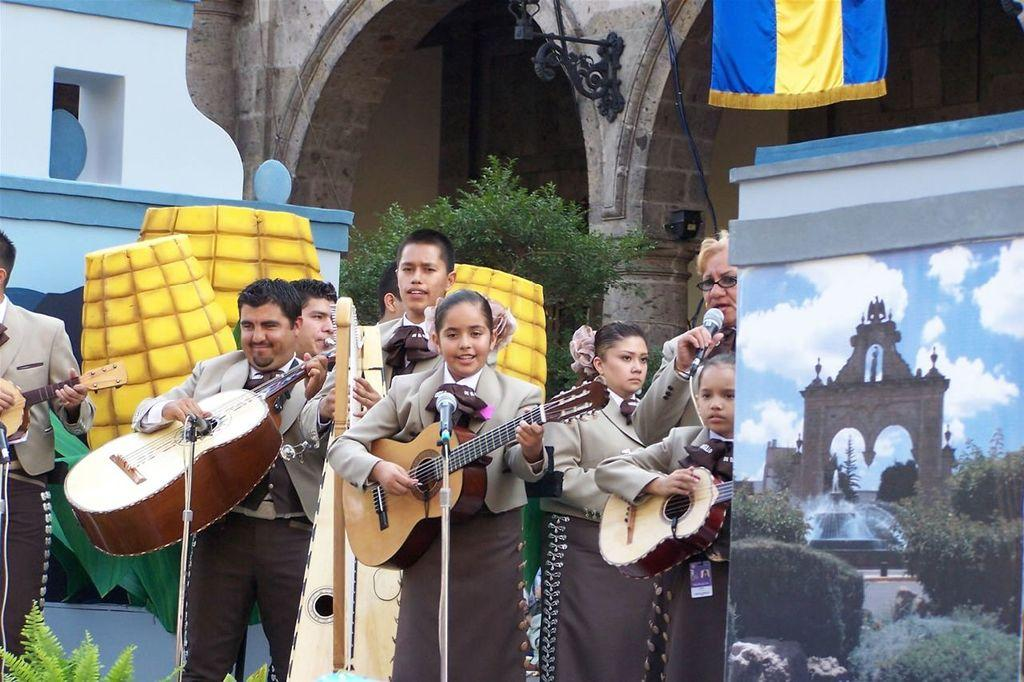What is the color of the wall in the image? The wall in the image is white. What type of natural element can be seen in the image? There is a tree in the image. What is hanging or attached in the image? There is a banner in the image. What type of structure is visible in the image? There is a building in the image. What are the people in the image holding? The people in the image are holding guitars. Can you tell me how many cans are visible in the image? There are no cans present in the image. What type of parent is shown in the image? There is no parent depicted in the image; it features a wall, a tree, a banner, a building, and people holding guitars. 